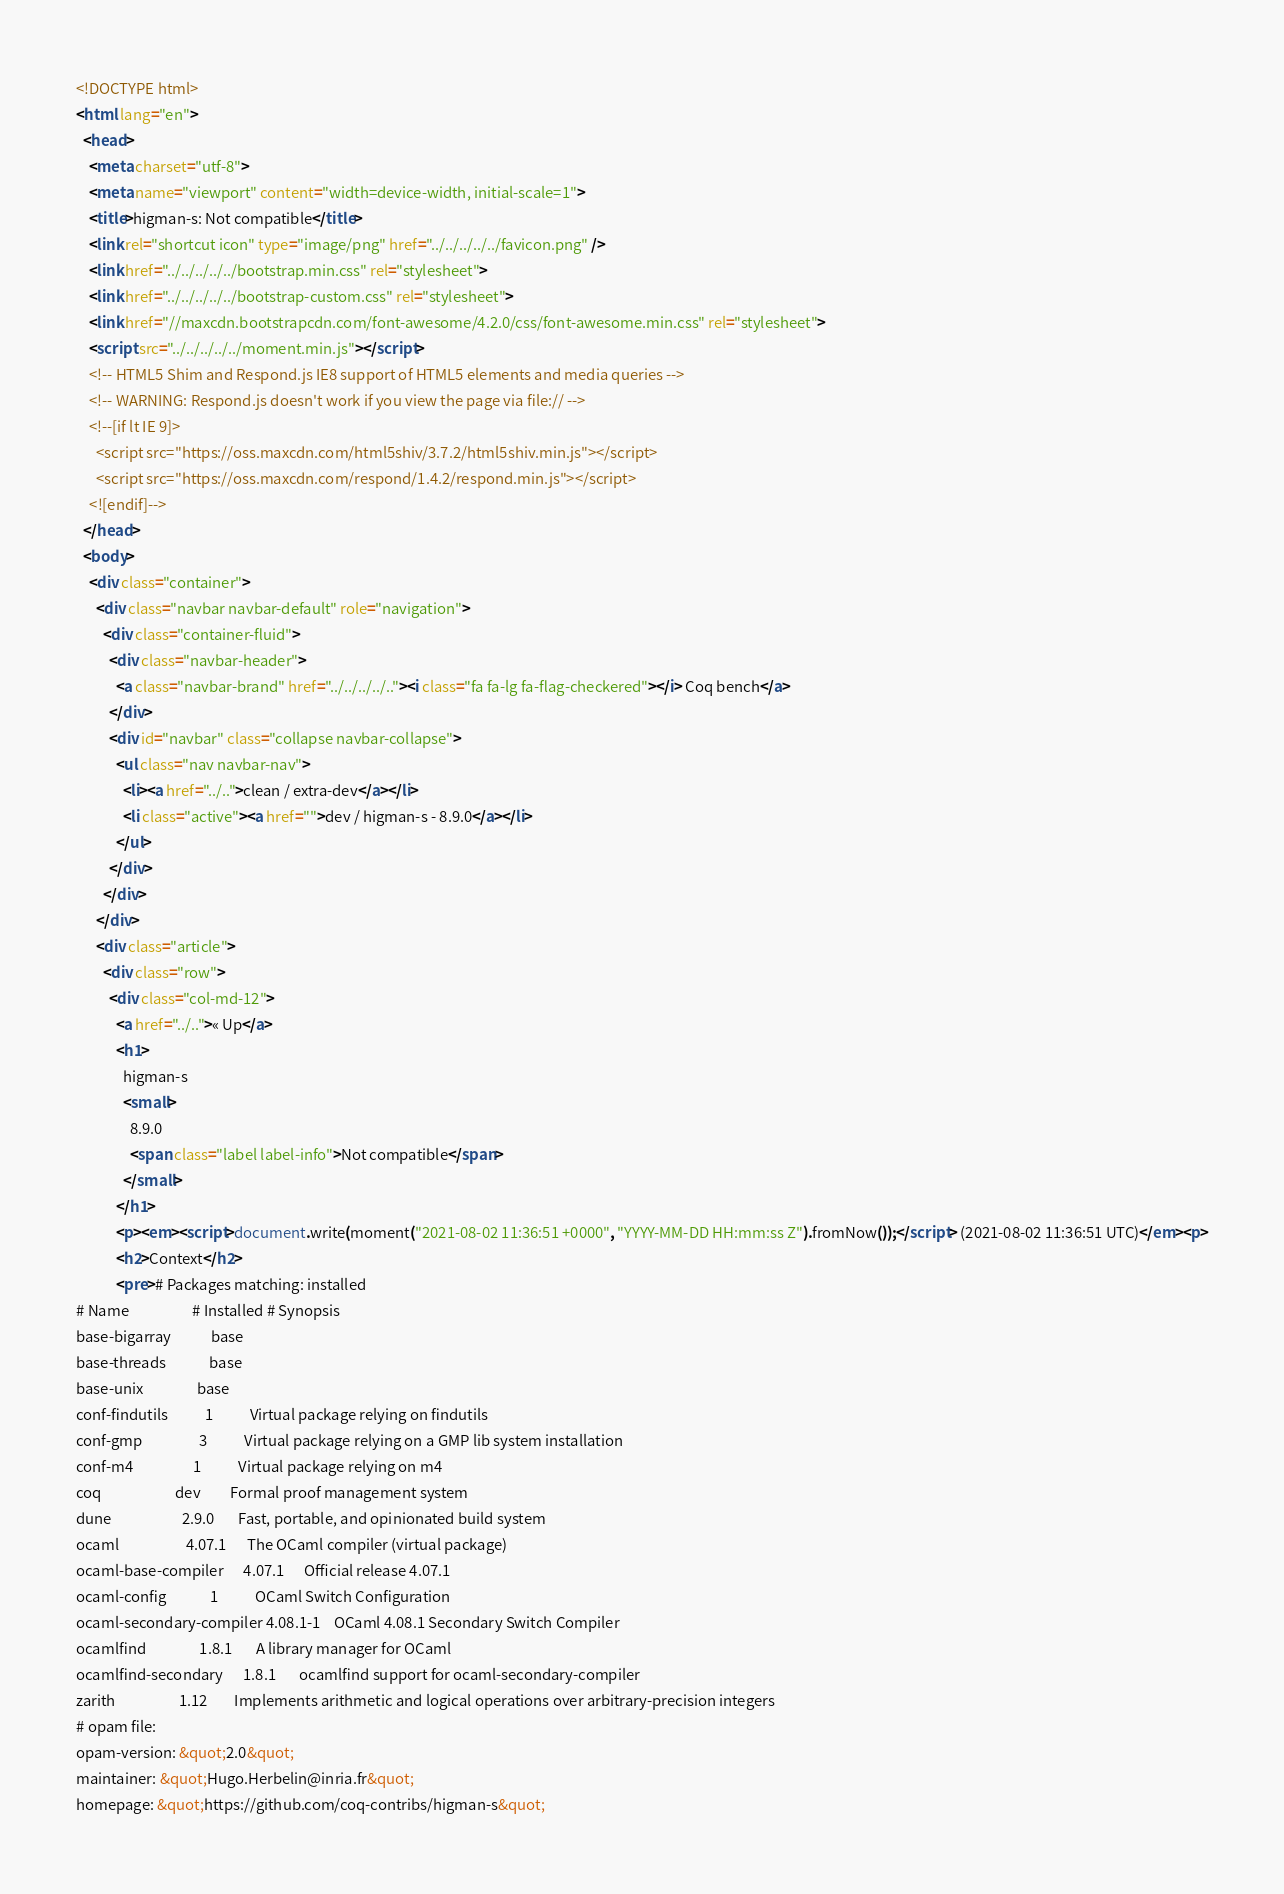Convert code to text. <code><loc_0><loc_0><loc_500><loc_500><_HTML_><!DOCTYPE html>
<html lang="en">
  <head>
    <meta charset="utf-8">
    <meta name="viewport" content="width=device-width, initial-scale=1">
    <title>higman-s: Not compatible</title>
    <link rel="shortcut icon" type="image/png" href="../../../../../favicon.png" />
    <link href="../../../../../bootstrap.min.css" rel="stylesheet">
    <link href="../../../../../bootstrap-custom.css" rel="stylesheet">
    <link href="//maxcdn.bootstrapcdn.com/font-awesome/4.2.0/css/font-awesome.min.css" rel="stylesheet">
    <script src="../../../../../moment.min.js"></script>
    <!-- HTML5 Shim and Respond.js IE8 support of HTML5 elements and media queries -->
    <!-- WARNING: Respond.js doesn't work if you view the page via file:// -->
    <!--[if lt IE 9]>
      <script src="https://oss.maxcdn.com/html5shiv/3.7.2/html5shiv.min.js"></script>
      <script src="https://oss.maxcdn.com/respond/1.4.2/respond.min.js"></script>
    <![endif]-->
  </head>
  <body>
    <div class="container">
      <div class="navbar navbar-default" role="navigation">
        <div class="container-fluid">
          <div class="navbar-header">
            <a class="navbar-brand" href="../../../../.."><i class="fa fa-lg fa-flag-checkered"></i> Coq bench</a>
          </div>
          <div id="navbar" class="collapse navbar-collapse">
            <ul class="nav navbar-nav">
              <li><a href="../..">clean / extra-dev</a></li>
              <li class="active"><a href="">dev / higman-s - 8.9.0</a></li>
            </ul>
          </div>
        </div>
      </div>
      <div class="article">
        <div class="row">
          <div class="col-md-12">
            <a href="../..">« Up</a>
            <h1>
              higman-s
              <small>
                8.9.0
                <span class="label label-info">Not compatible</span>
              </small>
            </h1>
            <p><em><script>document.write(moment("2021-08-02 11:36:51 +0000", "YYYY-MM-DD HH:mm:ss Z").fromNow());</script> (2021-08-02 11:36:51 UTC)</em><p>
            <h2>Context</h2>
            <pre># Packages matching: installed
# Name                   # Installed # Synopsis
base-bigarray            base
base-threads             base
base-unix                base
conf-findutils           1           Virtual package relying on findutils
conf-gmp                 3           Virtual package relying on a GMP lib system installation
conf-m4                  1           Virtual package relying on m4
coq                      dev         Formal proof management system
dune                     2.9.0       Fast, portable, and opinionated build system
ocaml                    4.07.1      The OCaml compiler (virtual package)
ocaml-base-compiler      4.07.1      Official release 4.07.1
ocaml-config             1           OCaml Switch Configuration
ocaml-secondary-compiler 4.08.1-1    OCaml 4.08.1 Secondary Switch Compiler
ocamlfind                1.8.1       A library manager for OCaml
ocamlfind-secondary      1.8.1       ocamlfind support for ocaml-secondary-compiler
zarith                   1.12        Implements arithmetic and logical operations over arbitrary-precision integers
# opam file:
opam-version: &quot;2.0&quot;
maintainer: &quot;Hugo.Herbelin@inria.fr&quot;
homepage: &quot;https://github.com/coq-contribs/higman-s&quot;</code> 